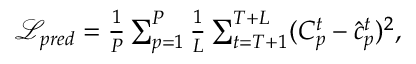<formula> <loc_0><loc_0><loc_500><loc_500>\begin{array} { r } { \begin{array} { r } { \mathcal { L } _ { p r e d } = \frac { 1 } { P } \sum _ { p = 1 } ^ { P } \frac { 1 } { L } \sum _ { t = T + 1 } ^ { T + L } ( C _ { p } ^ { t } - \hat { c } _ { p } ^ { t } ) ^ { 2 } , } \end{array} } \end{array}</formula> 